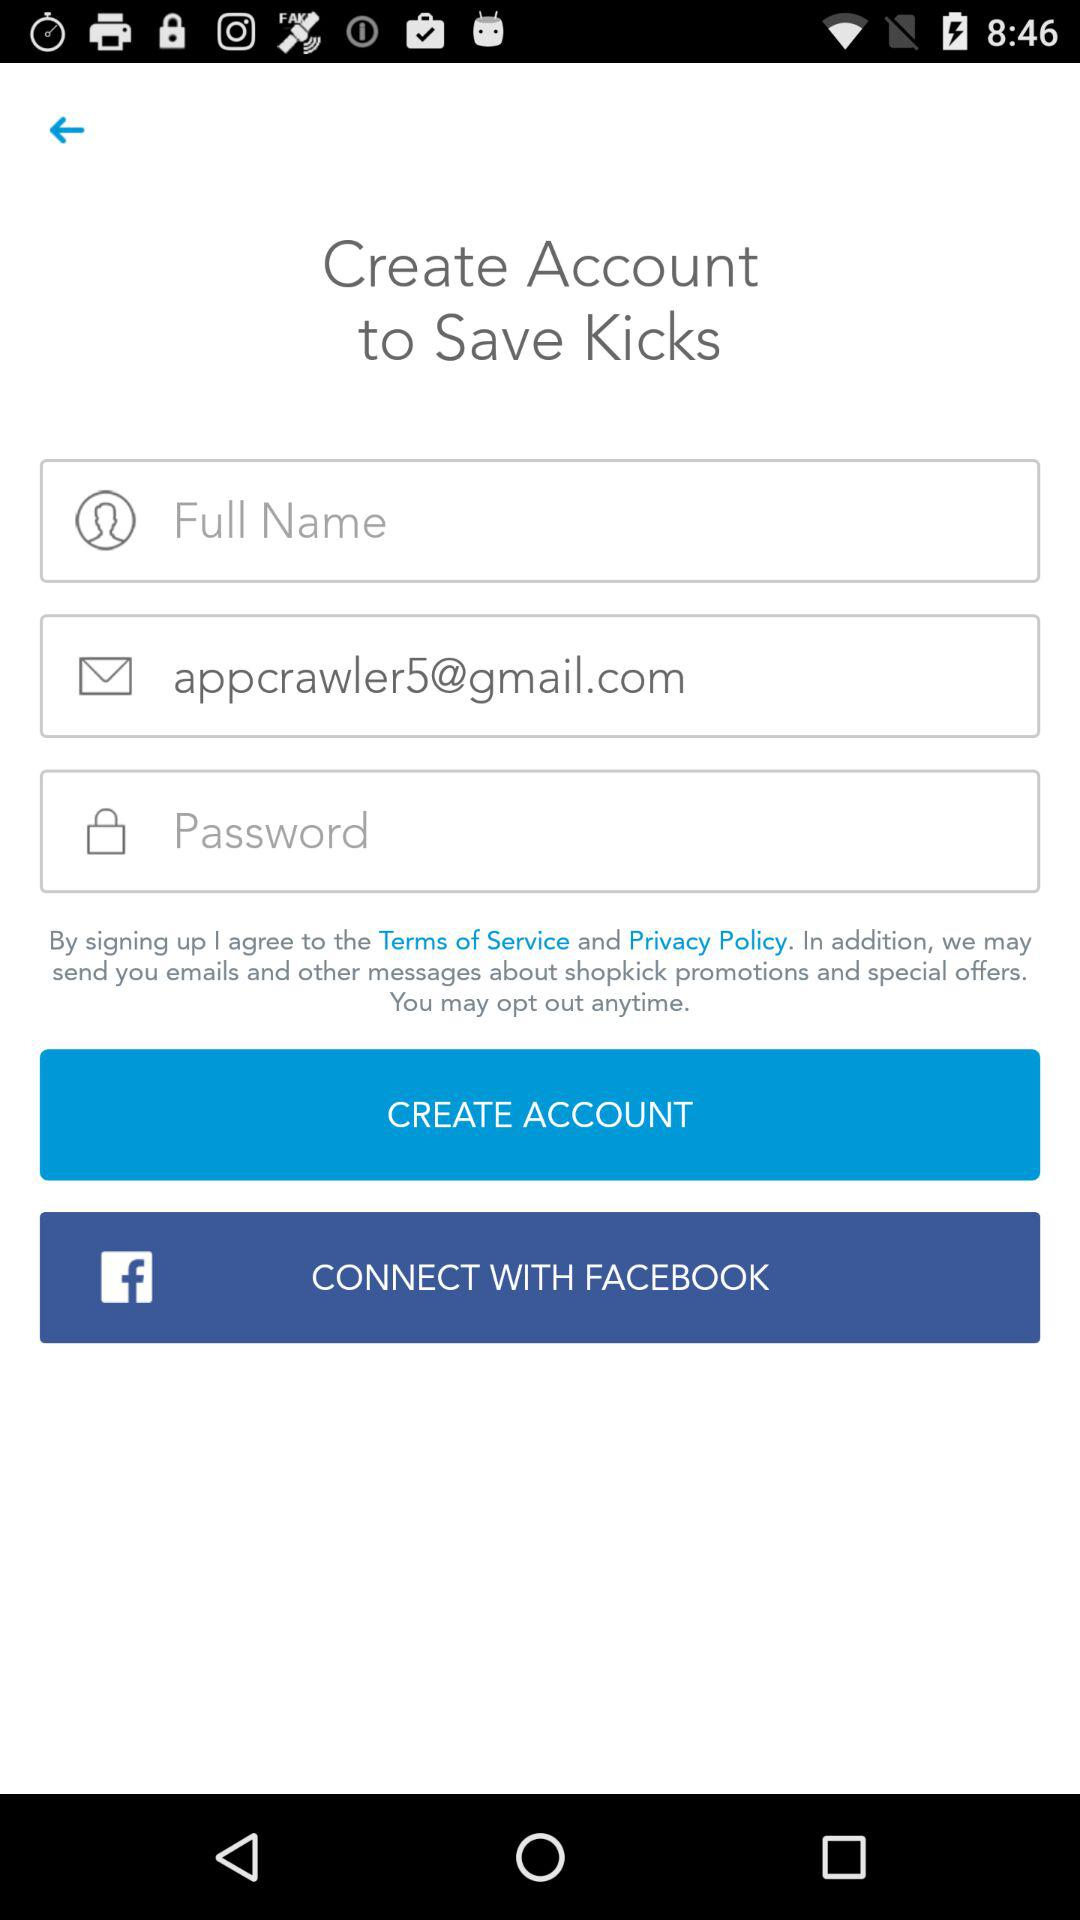How many text inputs are required to create an account?
Answer the question using a single word or phrase. 3 